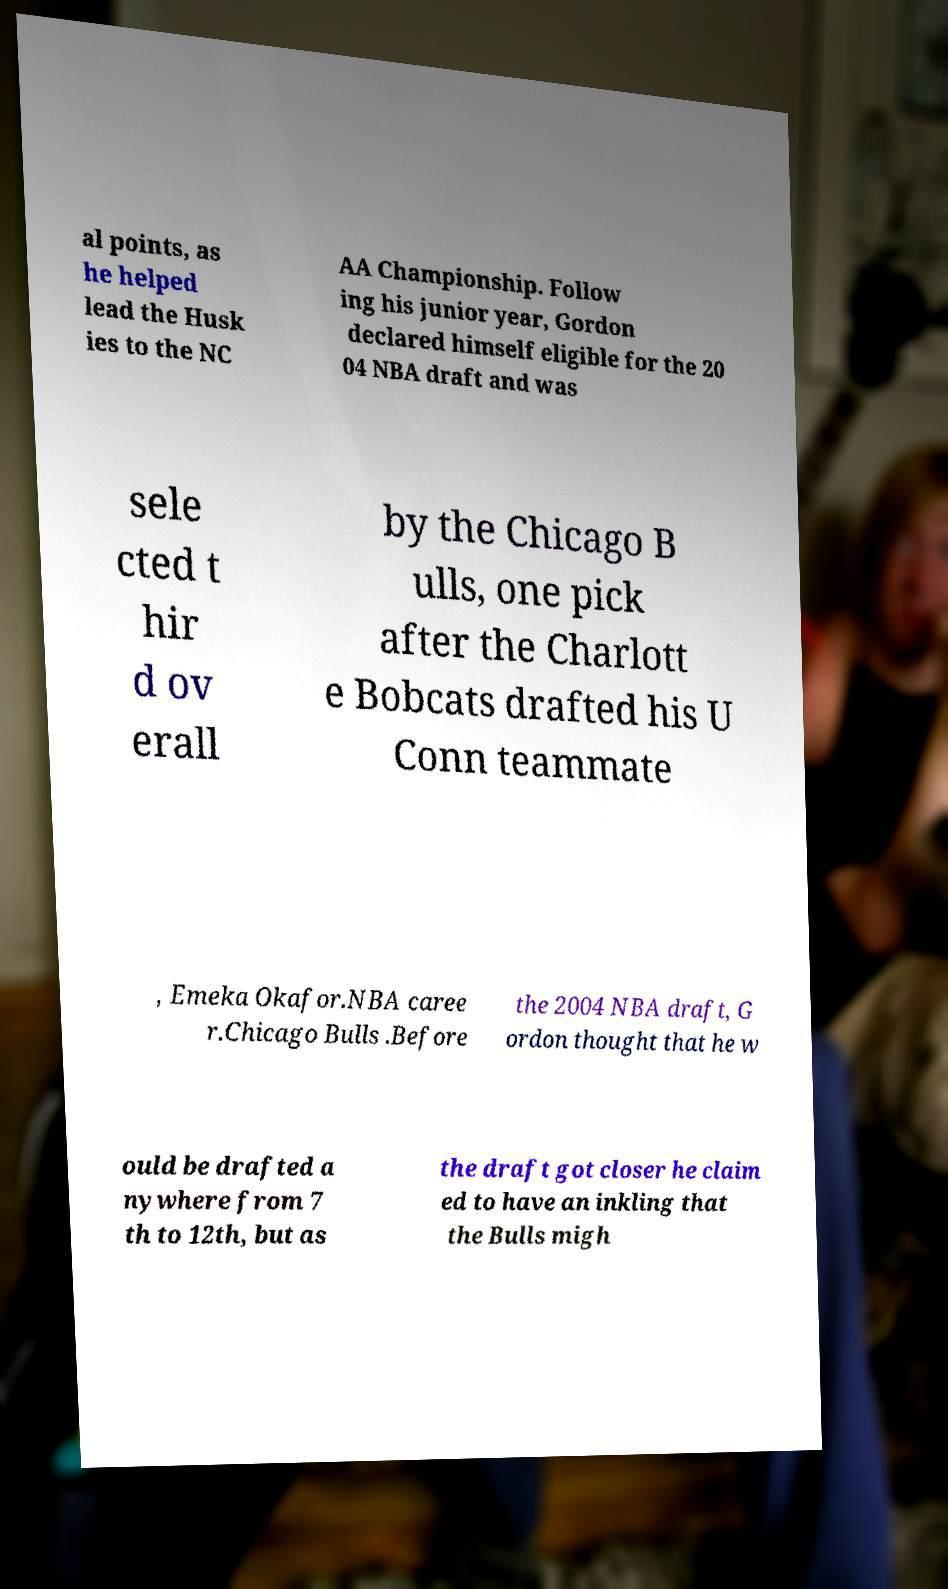What messages or text are displayed in this image? I need them in a readable, typed format. al points, as he helped lead the Husk ies to the NC AA Championship. Follow ing his junior year, Gordon declared himself eligible for the 20 04 NBA draft and was sele cted t hir d ov erall by the Chicago B ulls, one pick after the Charlott e Bobcats drafted his U Conn teammate , Emeka Okafor.NBA caree r.Chicago Bulls .Before the 2004 NBA draft, G ordon thought that he w ould be drafted a nywhere from 7 th to 12th, but as the draft got closer he claim ed to have an inkling that the Bulls migh 